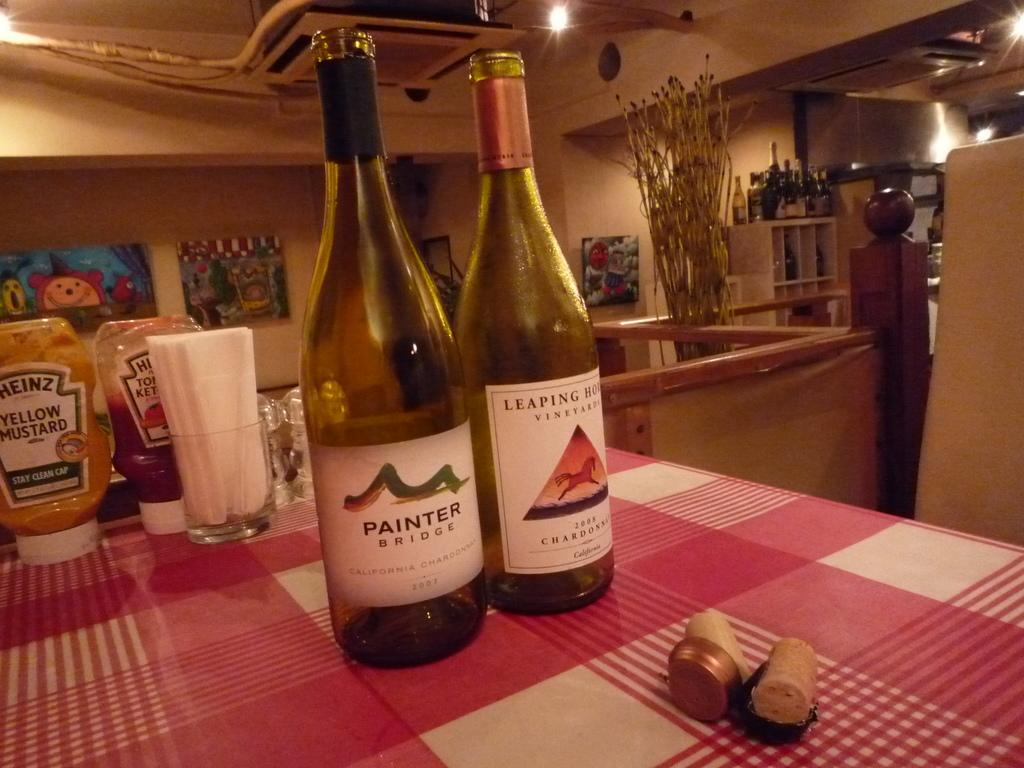<image>
Render a clear and concise summary of the photo. A bottle of Painter Bridge wine next to a bottle of Leaping Hound. 